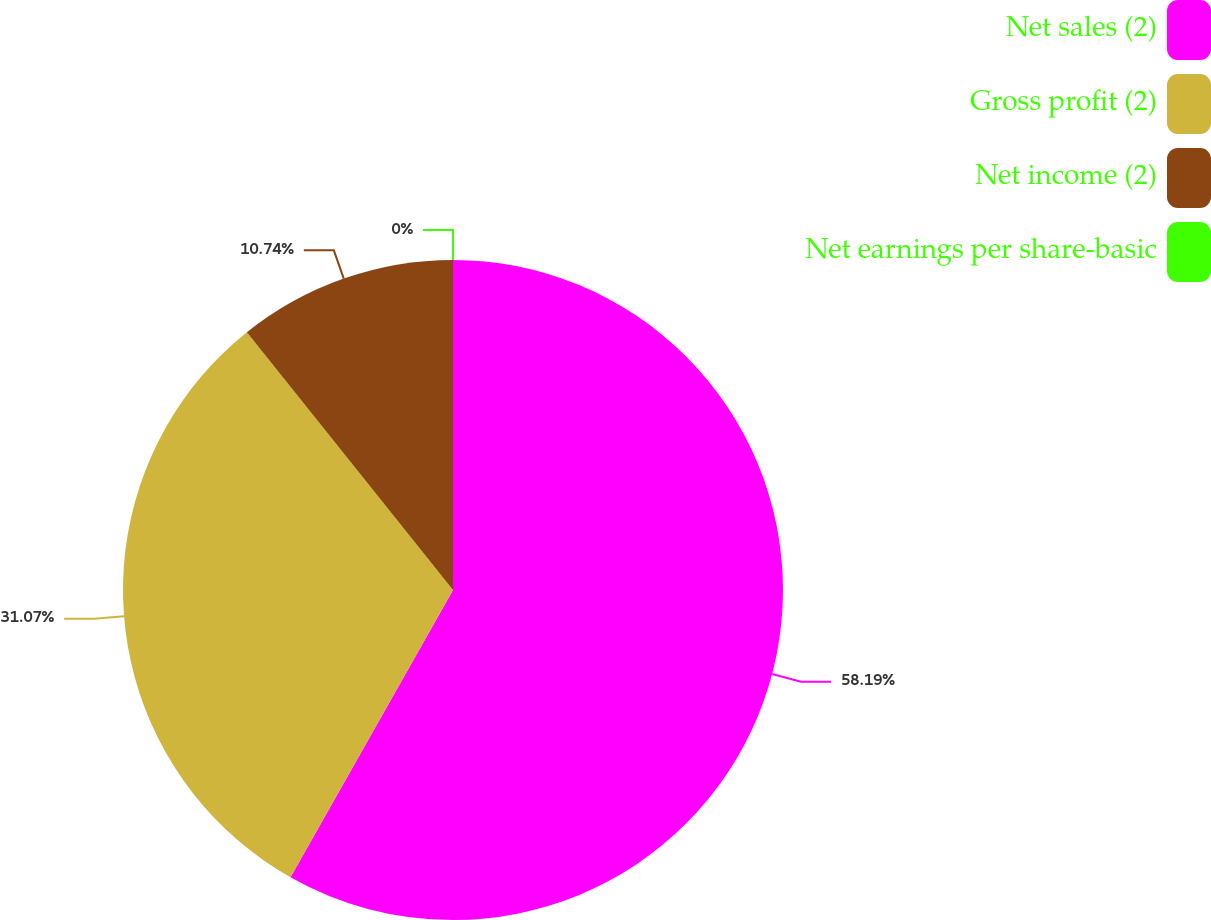<chart> <loc_0><loc_0><loc_500><loc_500><pie_chart><fcel>Net sales (2)<fcel>Gross profit (2)<fcel>Net income (2)<fcel>Net earnings per share-basic<nl><fcel>58.2%<fcel>31.07%<fcel>10.74%<fcel>0.0%<nl></chart> 